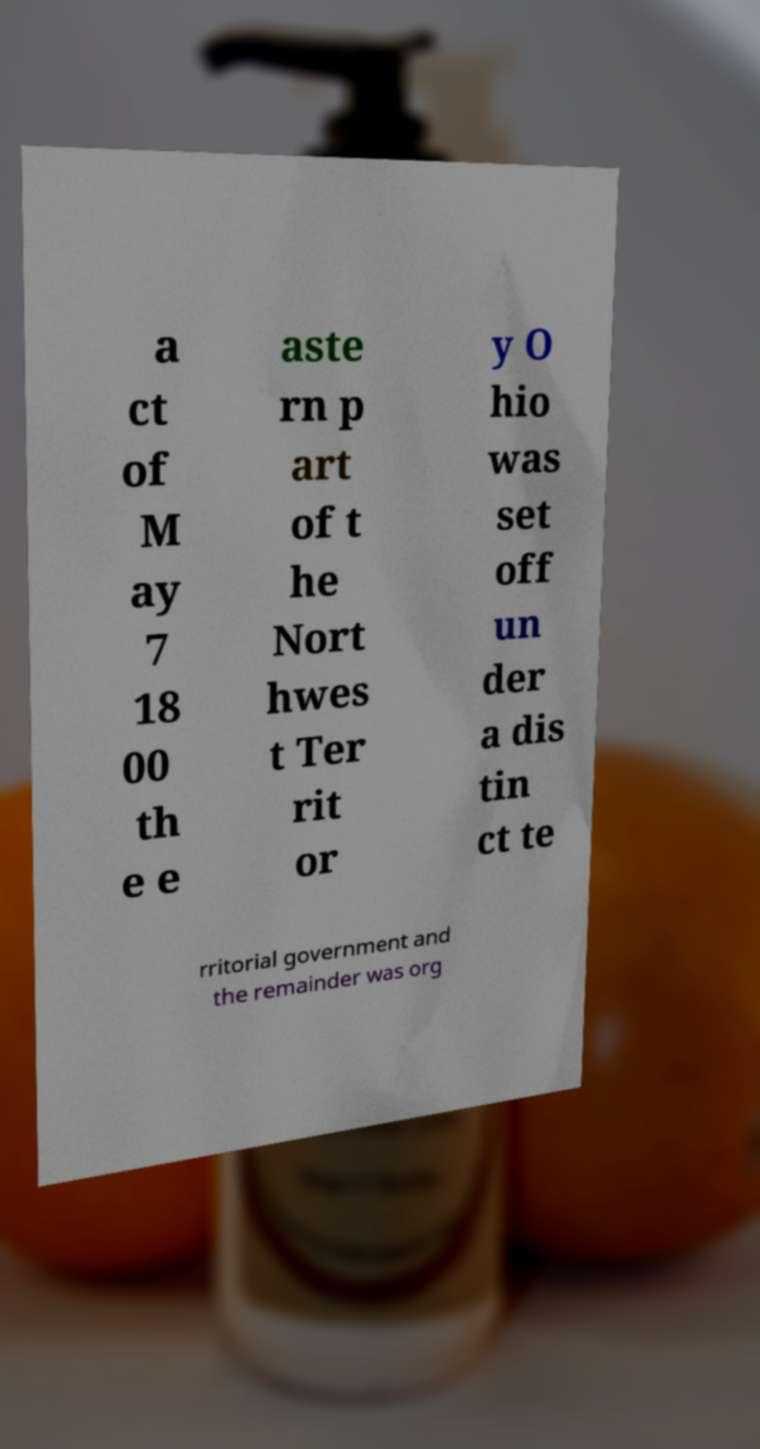There's text embedded in this image that I need extracted. Can you transcribe it verbatim? a ct of M ay 7 18 00 th e e aste rn p art of t he Nort hwes t Ter rit or y O hio was set off un der a dis tin ct te rritorial government and the remainder was org 